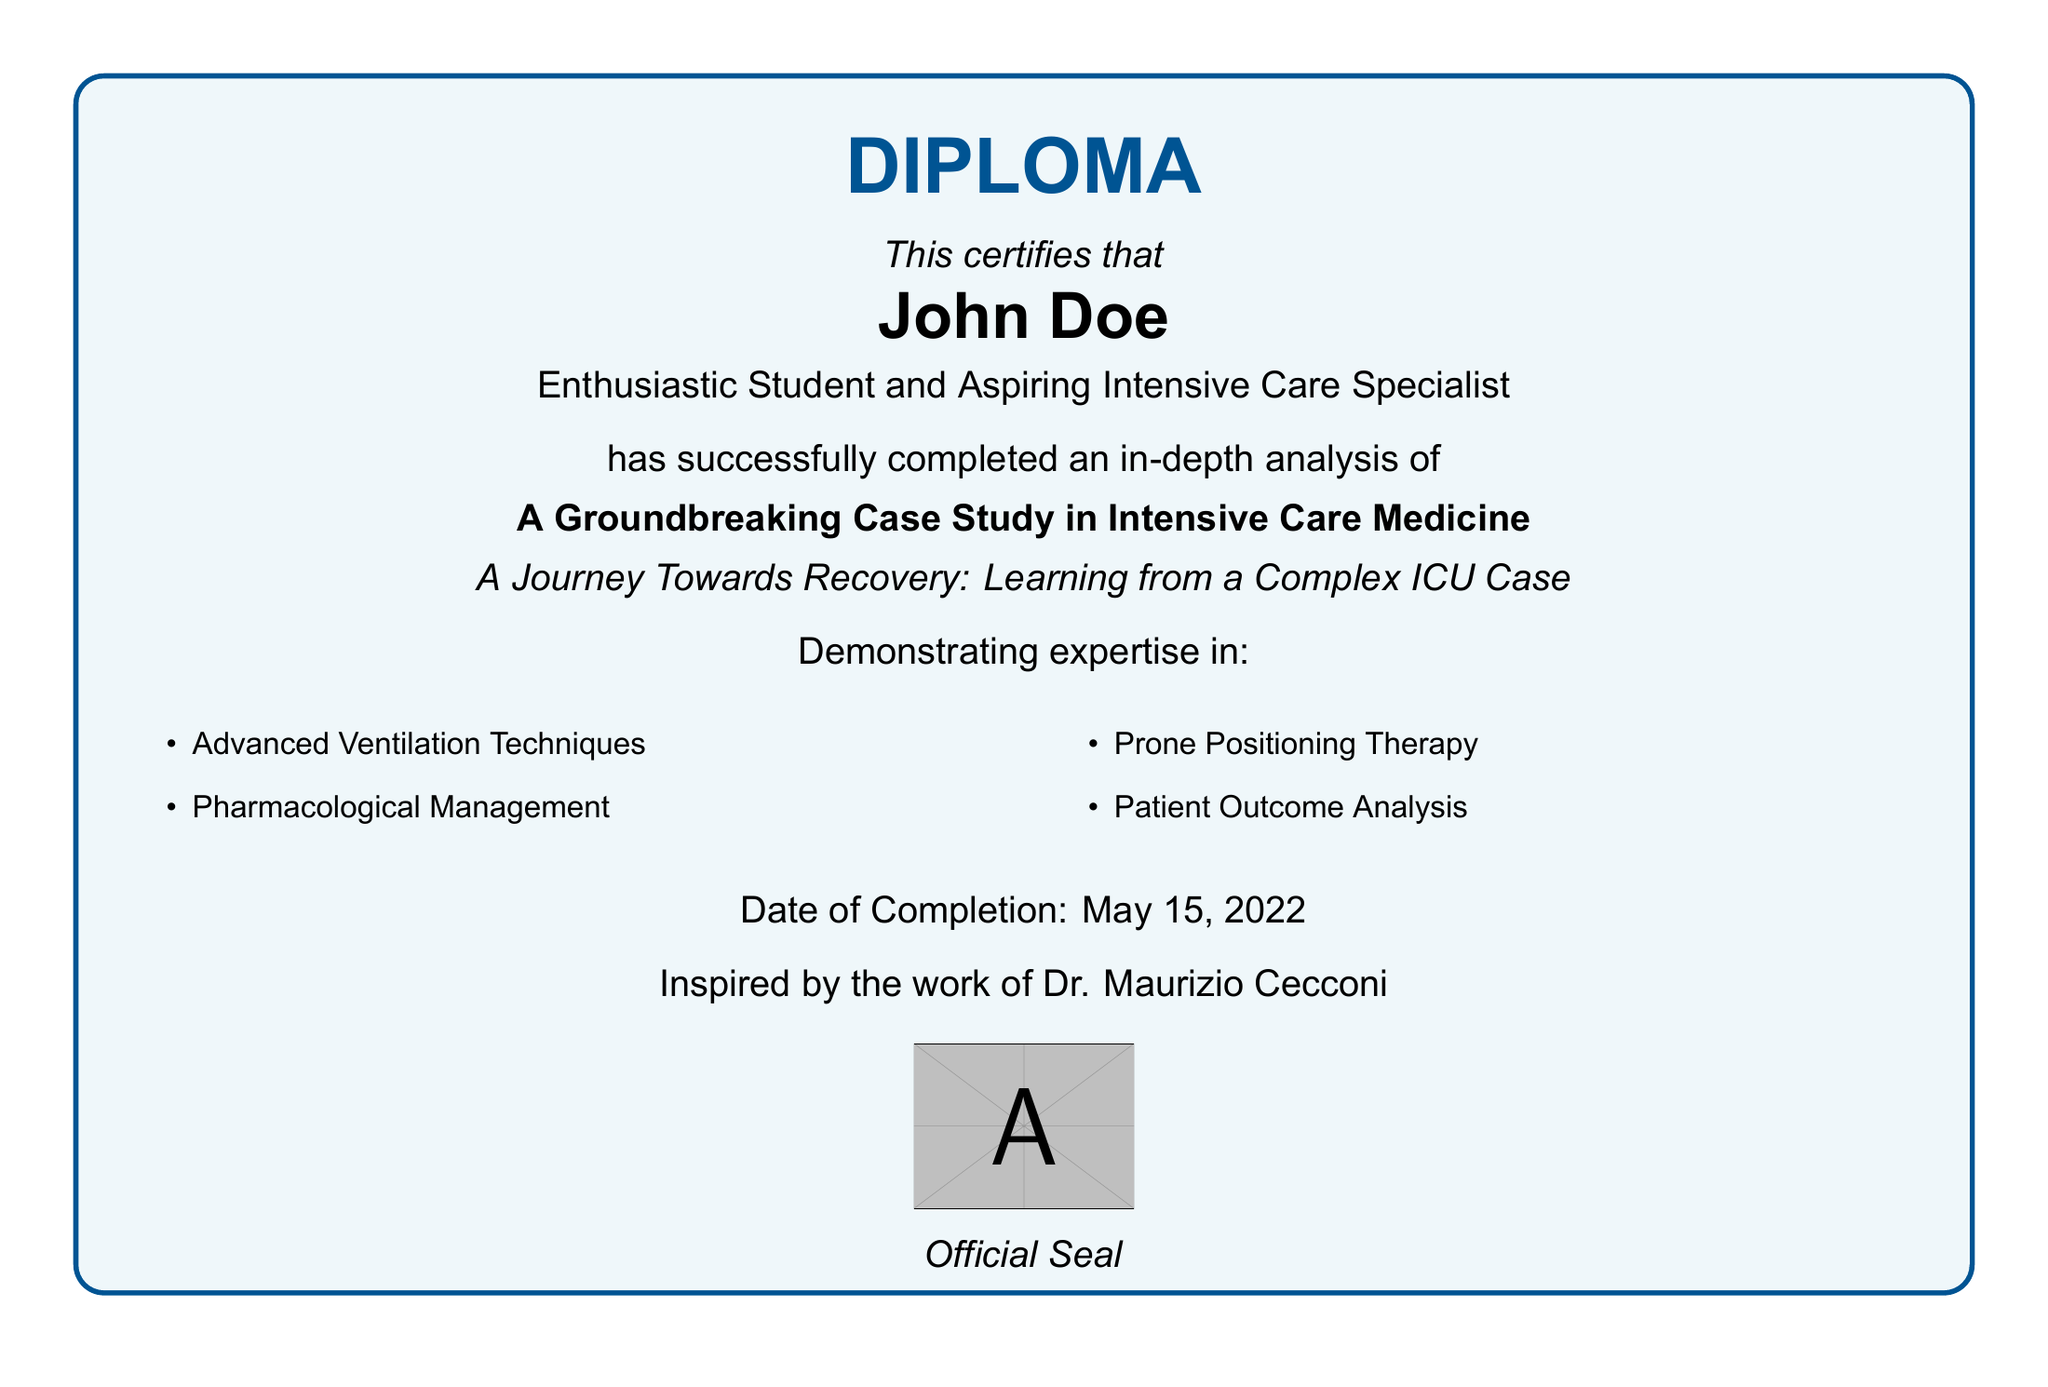What is the name of the student? The document certifies the completion of the analysis by John Doe.
Answer: John Doe What is the date of completion? The date mentioned in the document is when the student completed the analysis.
Answer: May 15, 2022 What is the title of the case study analyzed? The title of the case study mentioned in the diploma is a key focus point.
Answer: A Groundbreaking Case Study in Intensive Care Medicine Which expert inspired the student's work? The document indicates that the student's work was inspired by a well-known figure in intensive care medicine.
Answer: Dr. Maurizio Cecconi What is one of the demonstrated expertise areas? The document lists specific areas of expertise that the student has developed.
Answer: Advanced Ventilation Techniques How many areas of expertise are listed? The document contains a list that indicates the total number of expertise areas the student has successfully demonstrated.
Answer: Four What type of therapy is included in the expertise? Among the listed expertise areas, there is a mention of a particular therapeutic approach used in intensive care.
Answer: Prone Positioning Therapy What color is used for the border of the tcolorbox? The document specifies the color used for the box that frames the diploma's content.
Answer: medblue 